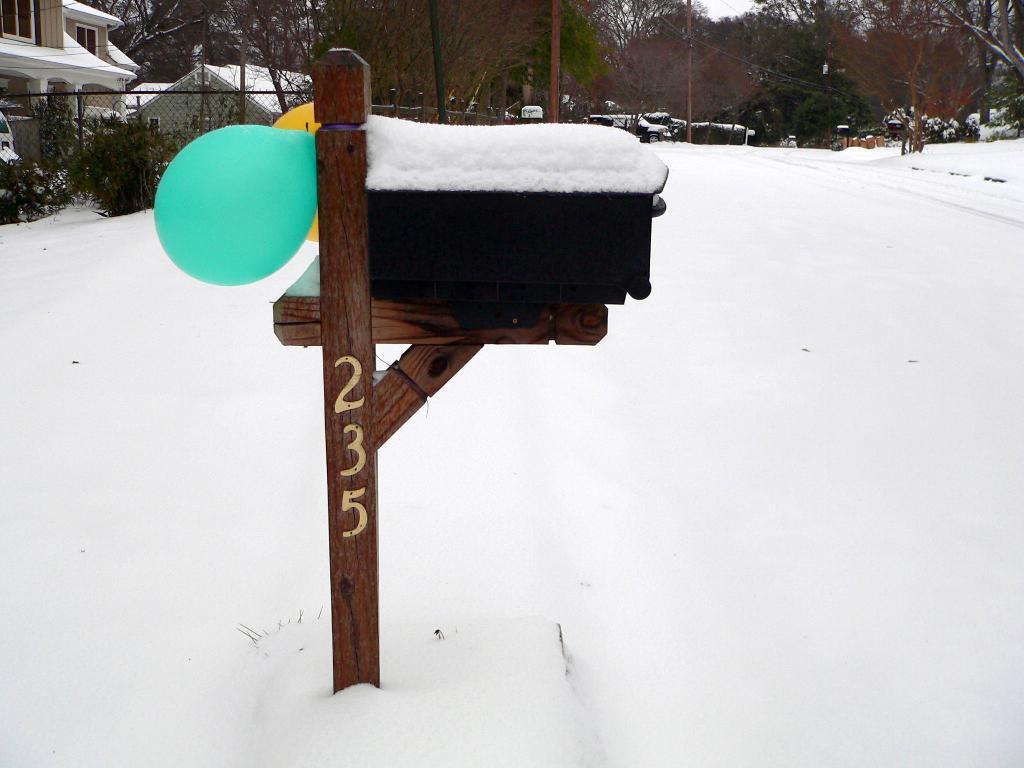Can you describe this image briefly? In this image we can see some snow on the stand which is tied with the balloons. On the backside we can see the houses with roofs, fence, trees, plants, pole, wires and the sky. 